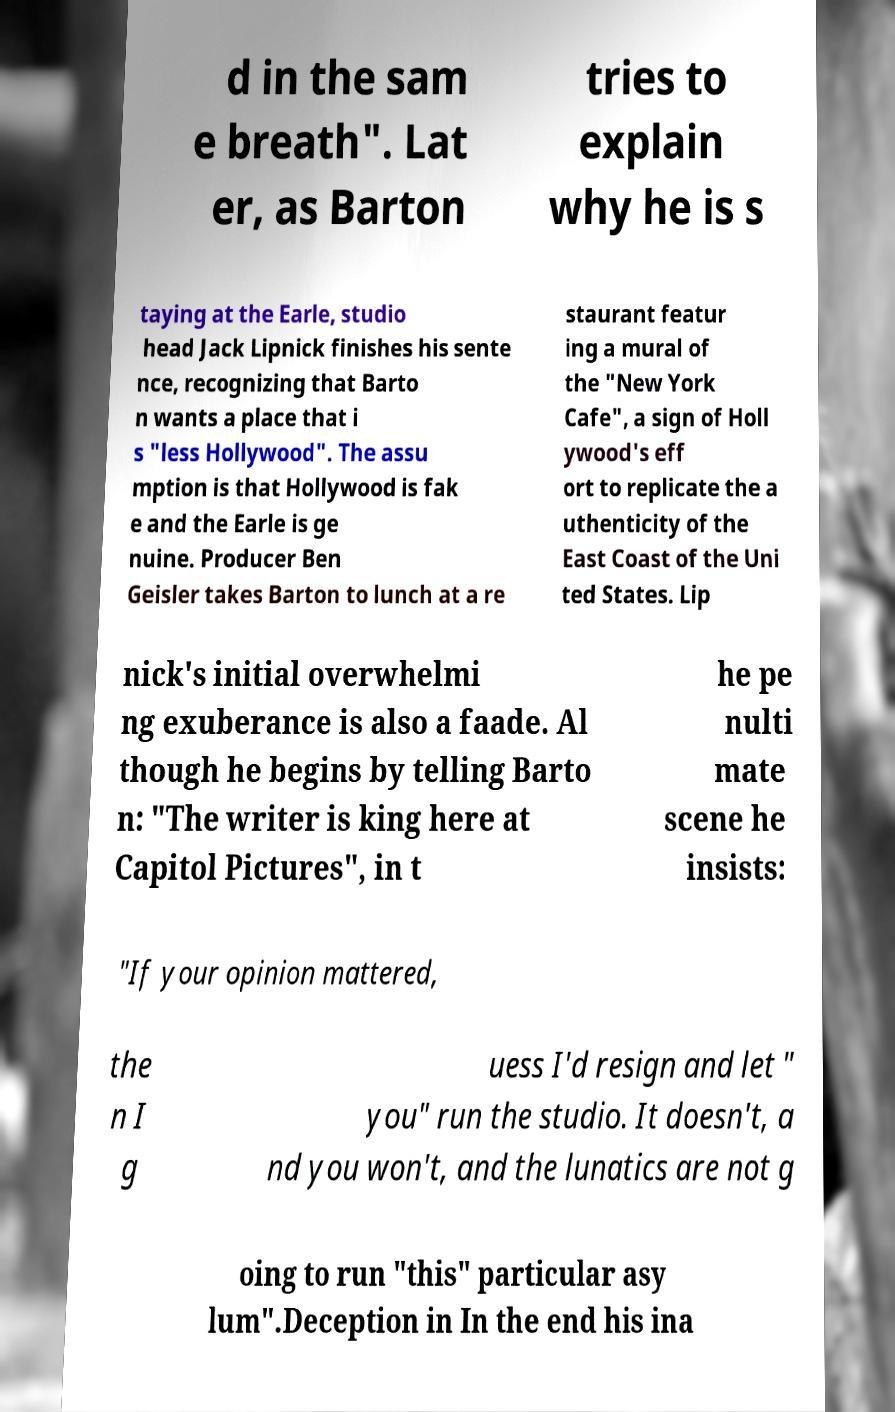Could you assist in decoding the text presented in this image and type it out clearly? d in the sam e breath". Lat er, as Barton tries to explain why he is s taying at the Earle, studio head Jack Lipnick finishes his sente nce, recognizing that Barto n wants a place that i s "less Hollywood". The assu mption is that Hollywood is fak e and the Earle is ge nuine. Producer Ben Geisler takes Barton to lunch at a re staurant featur ing a mural of the "New York Cafe", a sign of Holl ywood's eff ort to replicate the a uthenticity of the East Coast of the Uni ted States. Lip nick's initial overwhelmi ng exuberance is also a faade. Al though he begins by telling Barto n: "The writer is king here at Capitol Pictures", in t he pe nulti mate scene he insists: "If your opinion mattered, the n I g uess I'd resign and let " you" run the studio. It doesn't, a nd you won't, and the lunatics are not g oing to run "this" particular asy lum".Deception in In the end his ina 